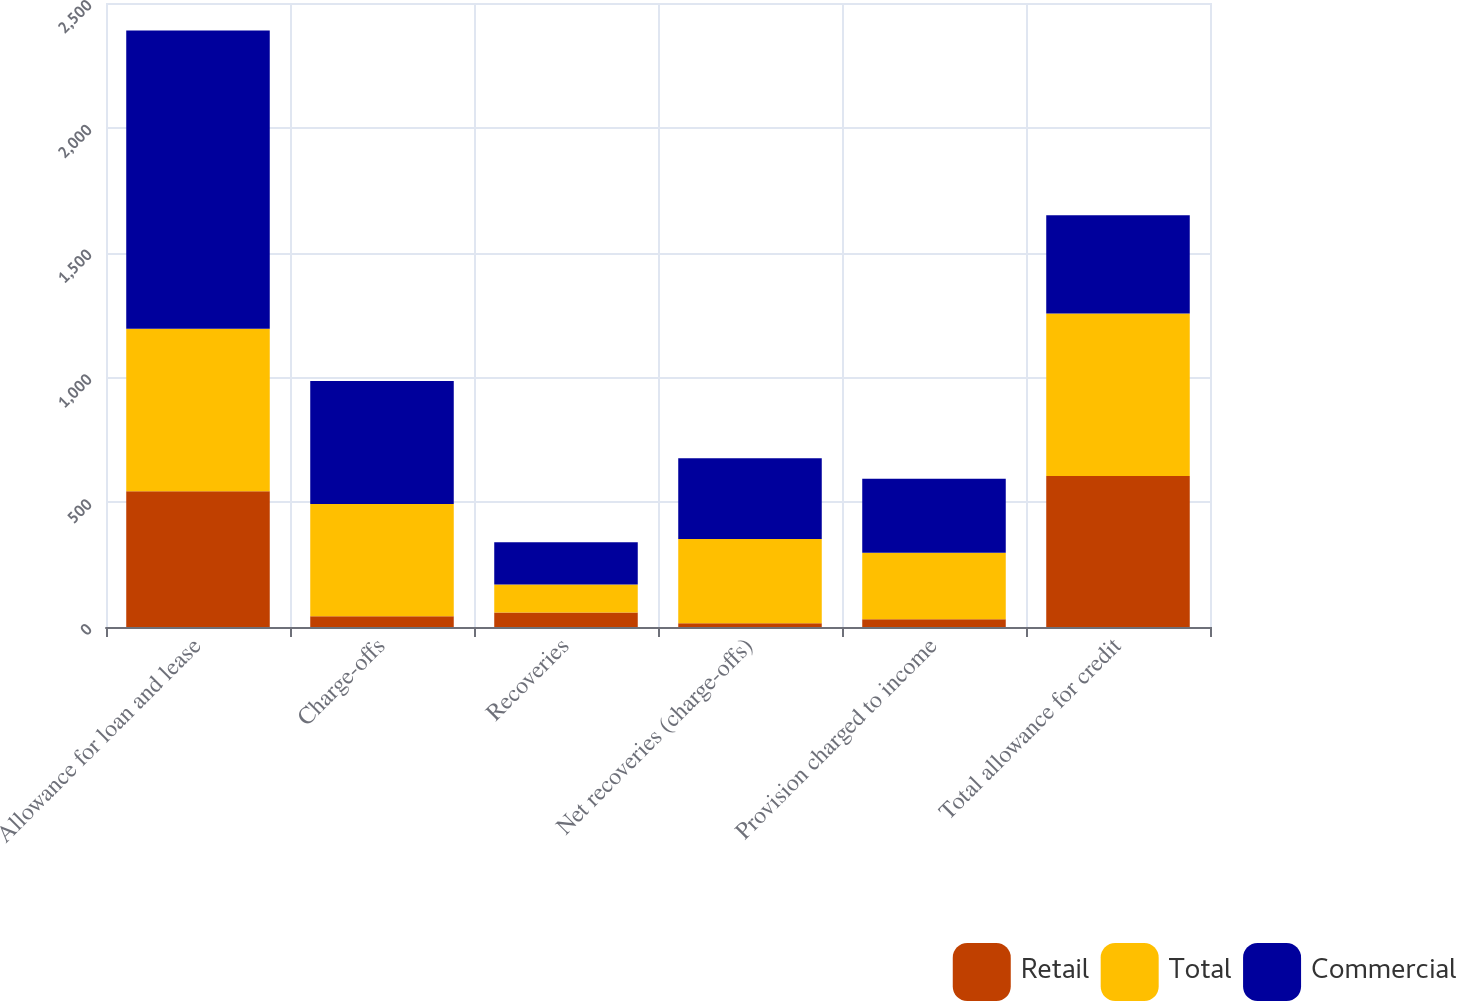Convert chart to OTSL. <chart><loc_0><loc_0><loc_500><loc_500><stacked_bar_chart><ecel><fcel>Allowance for loan and lease<fcel>Charge-offs<fcel>Recoveries<fcel>Net recoveries (charge-offs)<fcel>Provision charged to income<fcel>Total allowance for credit<nl><fcel>Retail<fcel>544<fcel>43<fcel>58<fcel>15<fcel>31<fcel>605<nl><fcel>Total<fcel>651<fcel>450<fcel>112<fcel>338<fcel>266<fcel>651<nl><fcel>Commercial<fcel>1195<fcel>493<fcel>170<fcel>323<fcel>297<fcel>394<nl></chart> 